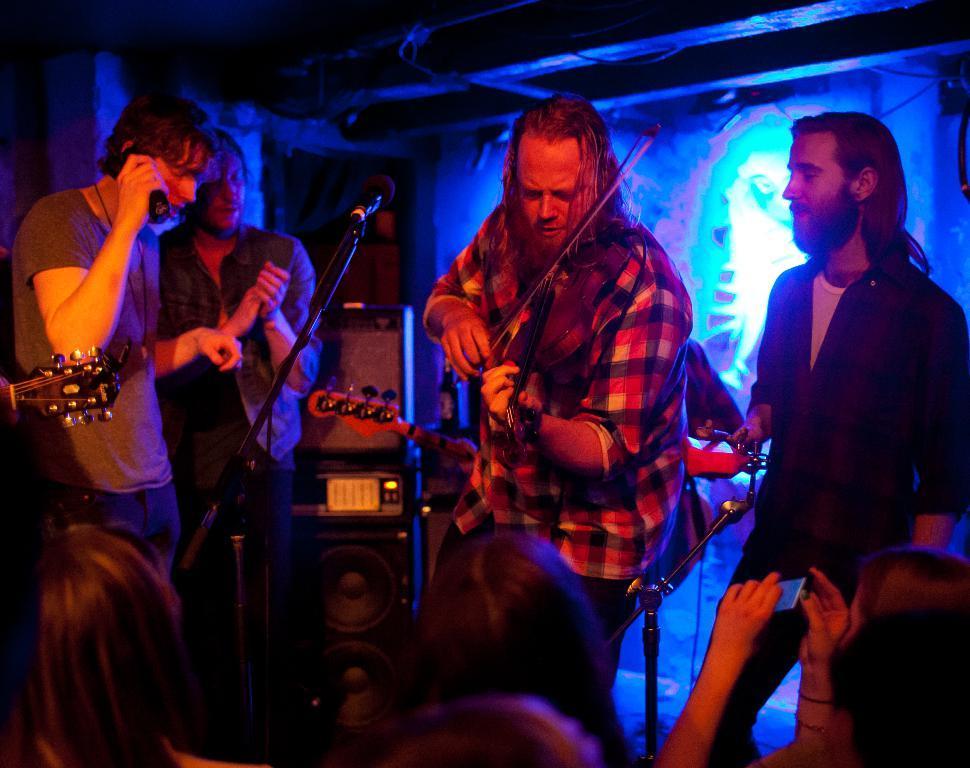Please provide a concise description of this image. In the center of the image we can see person holding violin and standing on the dais. On the right and left side of the image we can see persons on dais. At the bottom of the image we can see persons. In the background there is wall. 